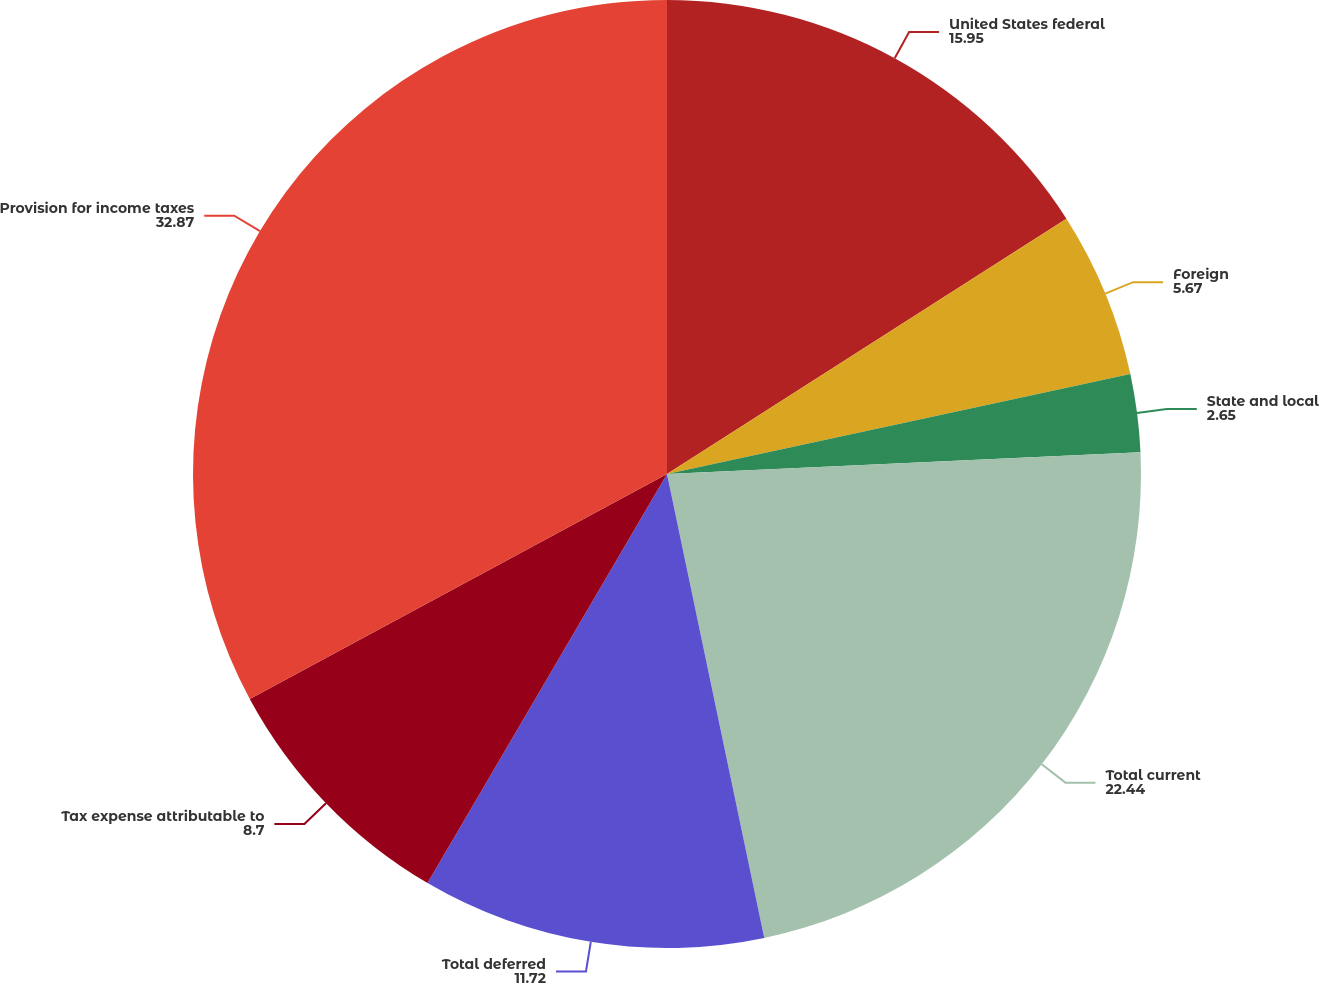Convert chart. <chart><loc_0><loc_0><loc_500><loc_500><pie_chart><fcel>United States federal<fcel>Foreign<fcel>State and local<fcel>Total current<fcel>Total deferred<fcel>Tax expense attributable to<fcel>Provision for income taxes<nl><fcel>15.95%<fcel>5.67%<fcel>2.65%<fcel>22.44%<fcel>11.72%<fcel>8.7%<fcel>32.87%<nl></chart> 